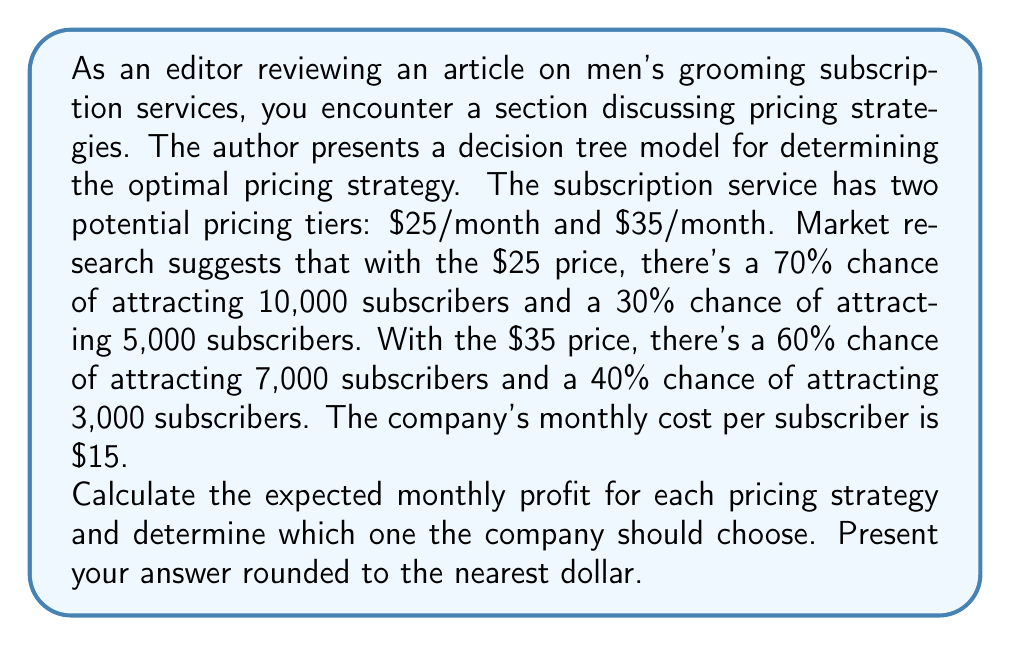Help me with this question. To solve this problem, we'll use a decision tree approach and calculate the expected value for each pricing strategy.

1. For the $25/month pricing strategy:

   a) Probability of 10,000 subscribers: 0.70
      Profit = $$(10,000 \times (25 - 15))$$ = $100,000
   
   b) Probability of 5,000 subscribers: 0.30
      Profit = $$(5,000 \times (25 - 15))$$ = $50,000

   Expected Value = $$(0.70 \times 100,000) + (0.30 \times 50,000)$$ = $70,000 + $15,000 = $85,000

2. For the $35/month pricing strategy:

   a) Probability of 7,000 subscribers: 0.60
      Profit = $$(7,000 \times (35 - 15))$$ = $140,000
   
   b) Probability of 3,000 subscribers: 0.40
      Profit = $$(3,000 \times (35 - 15))$$ = $60,000

   Expected Value = $$(0.60 \times 140,000) + (0.40 \times 60,000)$$ = $84,000 + $24,000 = $108,000

The expected monthly profit for the $25/month strategy is $85,000, while for the $35/month strategy, it's $108,000.
Answer: The company should choose the $35/month pricing strategy, as it has a higher expected monthly profit of $108,000 compared to $85,000 for the $25/month strategy. 